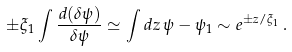Convert formula to latex. <formula><loc_0><loc_0><loc_500><loc_500>\pm \xi _ { 1 } \int \frac { d ( \delta \psi ) } { \delta \psi } \simeq \int d z \, \psi - \psi _ { 1 } \sim e ^ { \pm z / \xi _ { 1 } } \, .</formula> 